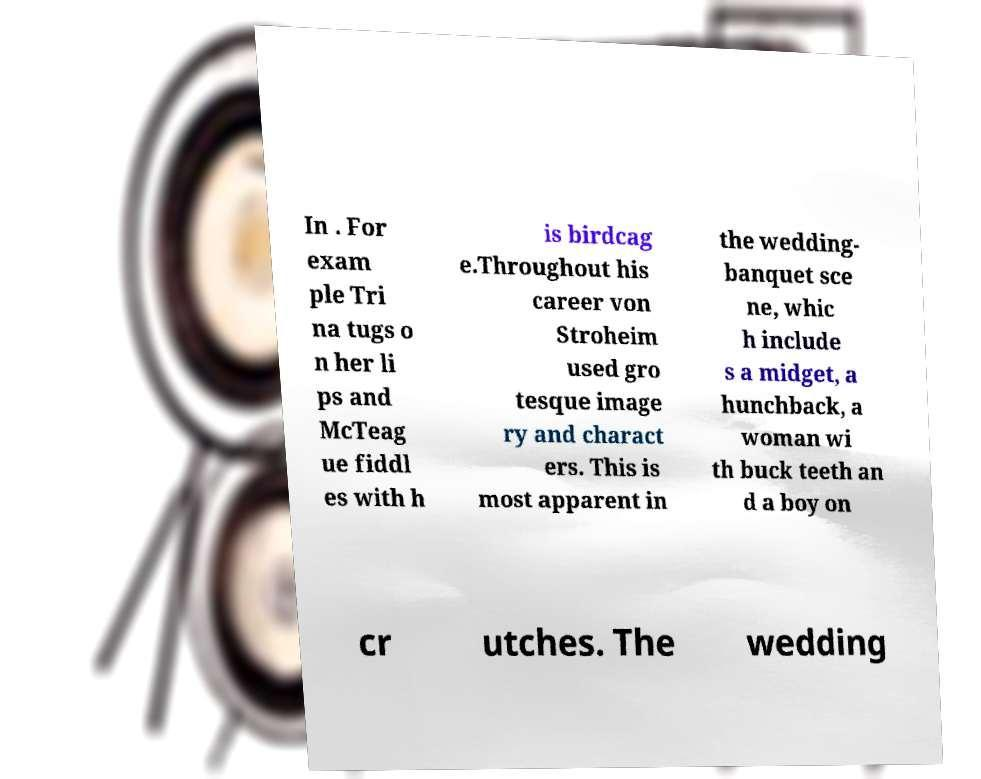What messages or text are displayed in this image? I need them in a readable, typed format. In . For exam ple Tri na tugs o n her li ps and McTeag ue fiddl es with h is birdcag e.Throughout his career von Stroheim used gro tesque image ry and charact ers. This is most apparent in the wedding- banquet sce ne, whic h include s a midget, a hunchback, a woman wi th buck teeth an d a boy on cr utches. The wedding 